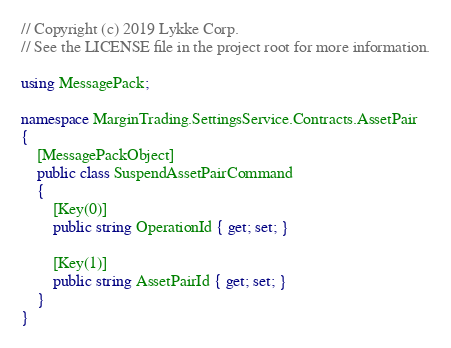Convert code to text. <code><loc_0><loc_0><loc_500><loc_500><_C#_>// Copyright (c) 2019 Lykke Corp.
// See the LICENSE file in the project root for more information.

using MessagePack;

namespace MarginTrading.SettingsService.Contracts.AssetPair
{
    [MessagePackObject]
    public class SuspendAssetPairCommand
    {
        [Key(0)]
        public string OperationId { get; set; }
        
        [Key(1)]
        public string AssetPairId { get; set; }
    }
}</code> 